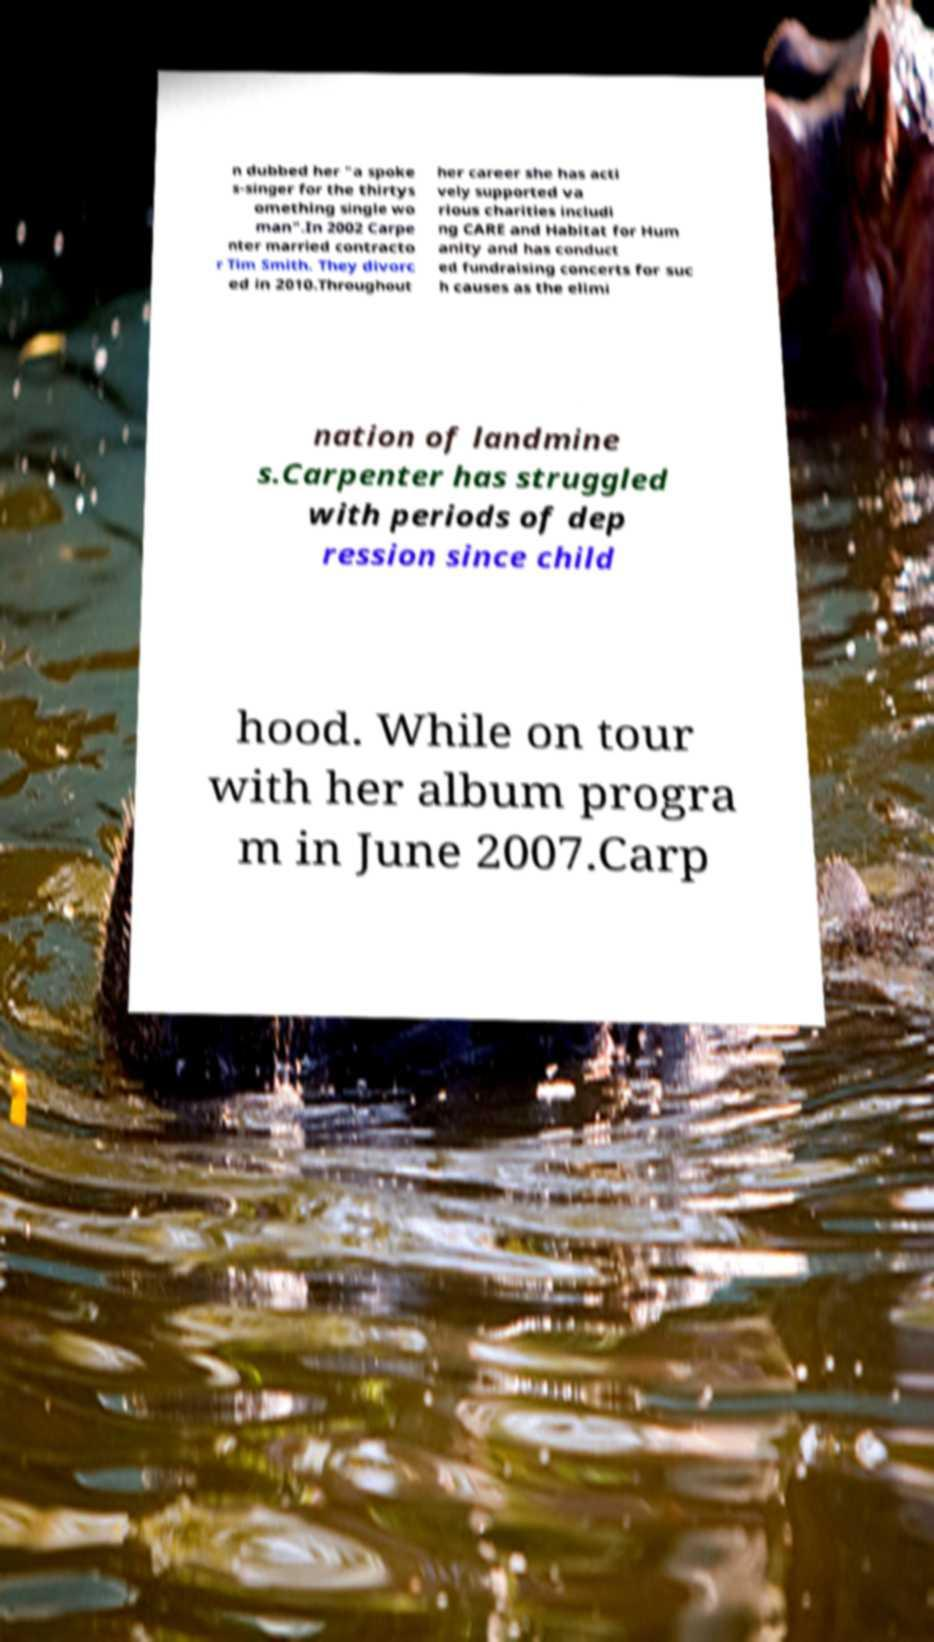Please read and relay the text visible in this image. What does it say? n dubbed her "a spoke s-singer for the thirtys omething single wo man".In 2002 Carpe nter married contracto r Tim Smith. They divorc ed in 2010.Throughout her career she has acti vely supported va rious charities includi ng CARE and Habitat for Hum anity and has conduct ed fundraising concerts for suc h causes as the elimi nation of landmine s.Carpenter has struggled with periods of dep ression since child hood. While on tour with her album progra m in June 2007.Carp 